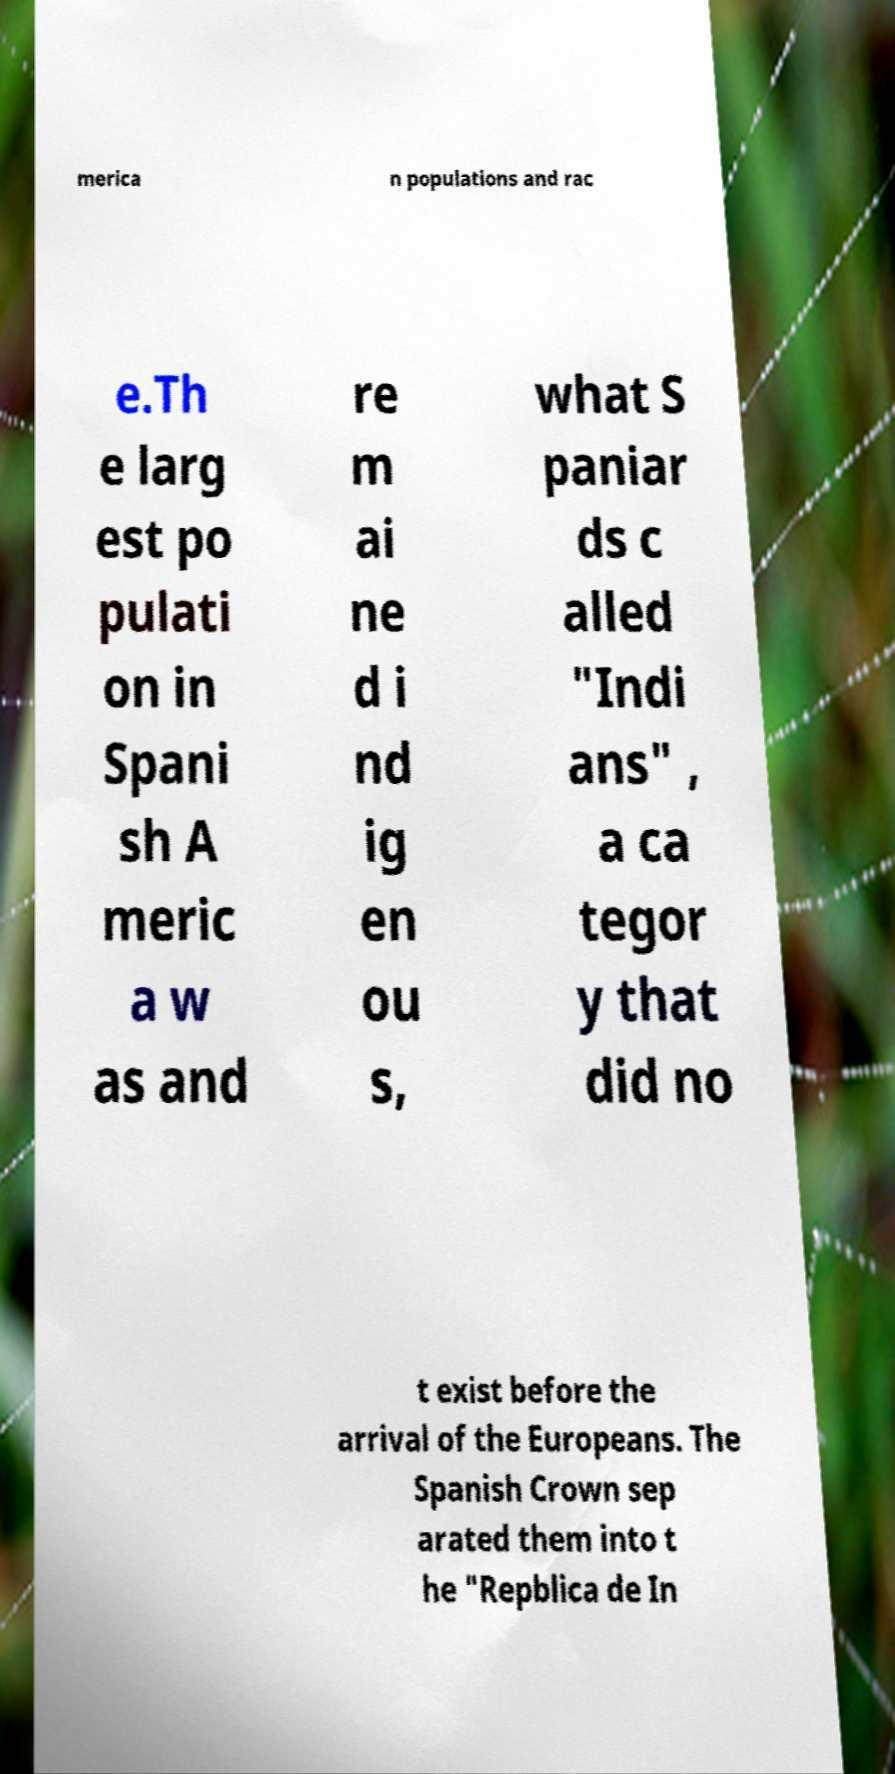Could you extract and type out the text from this image? merica n populations and rac e.Th e larg est po pulati on in Spani sh A meric a w as and re m ai ne d i nd ig en ou s, what S paniar ds c alled "Indi ans" , a ca tegor y that did no t exist before the arrival of the Europeans. The Spanish Crown sep arated them into t he "Repblica de In 